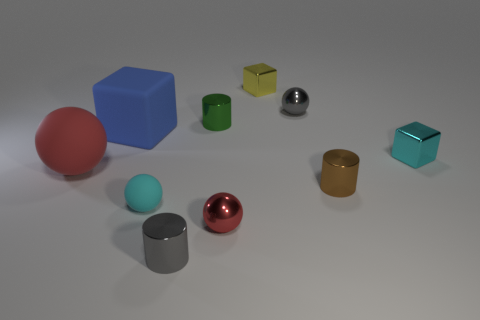Does the small brown shiny thing have the same shape as the gray object that is in front of the small cyan sphere?
Make the answer very short. Yes. There is a gray object left of the small gray object behind the blue cube; what is its material?
Give a very brief answer. Metal. Are there an equal number of big red matte balls right of the tiny green metal cylinder and large red things?
Provide a succinct answer. No. There is a large thing that is in front of the large blue object; is its color the same as the tiny shiny cylinder that is on the right side of the tiny yellow block?
Offer a terse response. No. What number of small objects are both right of the tiny green cylinder and behind the blue rubber thing?
Your response must be concise. 2. What number of other things are there of the same shape as the small yellow thing?
Ensure brevity in your answer.  2. Is the number of gray spheres to the left of the small yellow shiny thing greater than the number of small brown metallic objects?
Your answer should be compact. No. What color is the small cube that is behind the blue object?
Provide a short and direct response. Yellow. The cube that is the same color as the tiny matte thing is what size?
Provide a succinct answer. Small. What number of rubber things are big red things or big cubes?
Provide a short and direct response. 2. 